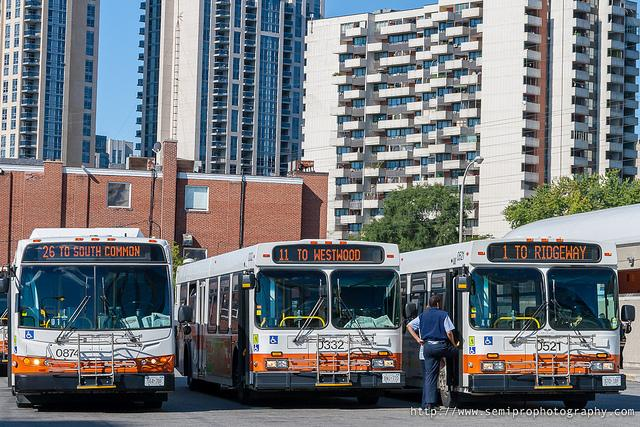The man standing near the buses is probably there to do what? Please explain your reasoning. drive. The man is driving. 